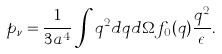Convert formula to latex. <formula><loc_0><loc_0><loc_500><loc_500>p _ { \nu } = \frac { 1 } { 3 a ^ { 4 } } \int q ^ { 2 } d q d \Omega f _ { 0 } ( q ) \frac { q ^ { 2 } } { \epsilon } .</formula> 